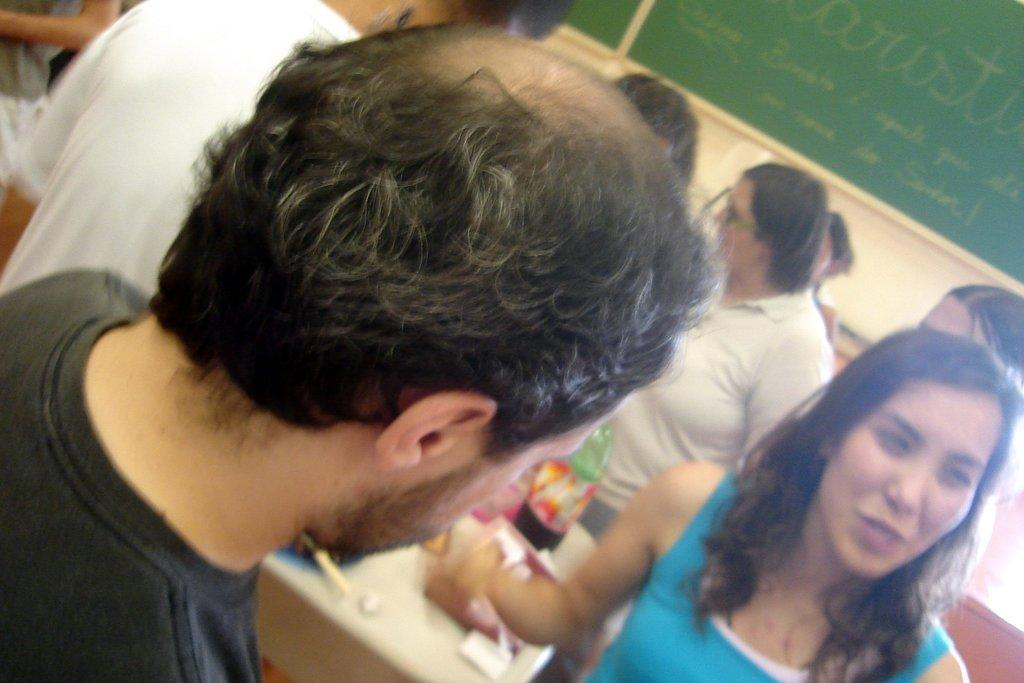How many people are in the image? There is a group of people standing in the image. What can be seen on the table in the image? There are objects on a table in the image, including a bottle. What is on the wall in the background of the image? There are boards on the wall in the background of the image. What type of spy equipment can be seen on the table in the image? There is no spy equipment present in the image; it features a group of people and objects on a table. What type of fuel is being used by the people in the image? There is no indication of any fuel being used in the image; it features a group of people and objects on a table. 